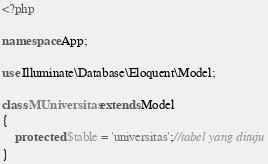Convert code to text. <code><loc_0><loc_0><loc_500><loc_500><_PHP_><?php

namespace App;

use Illuminate\Database\Eloquent\Model;

class MUniversitas extends Model
{
    protected $table = 'universitas';//tabel yang dituju
}
</code> 